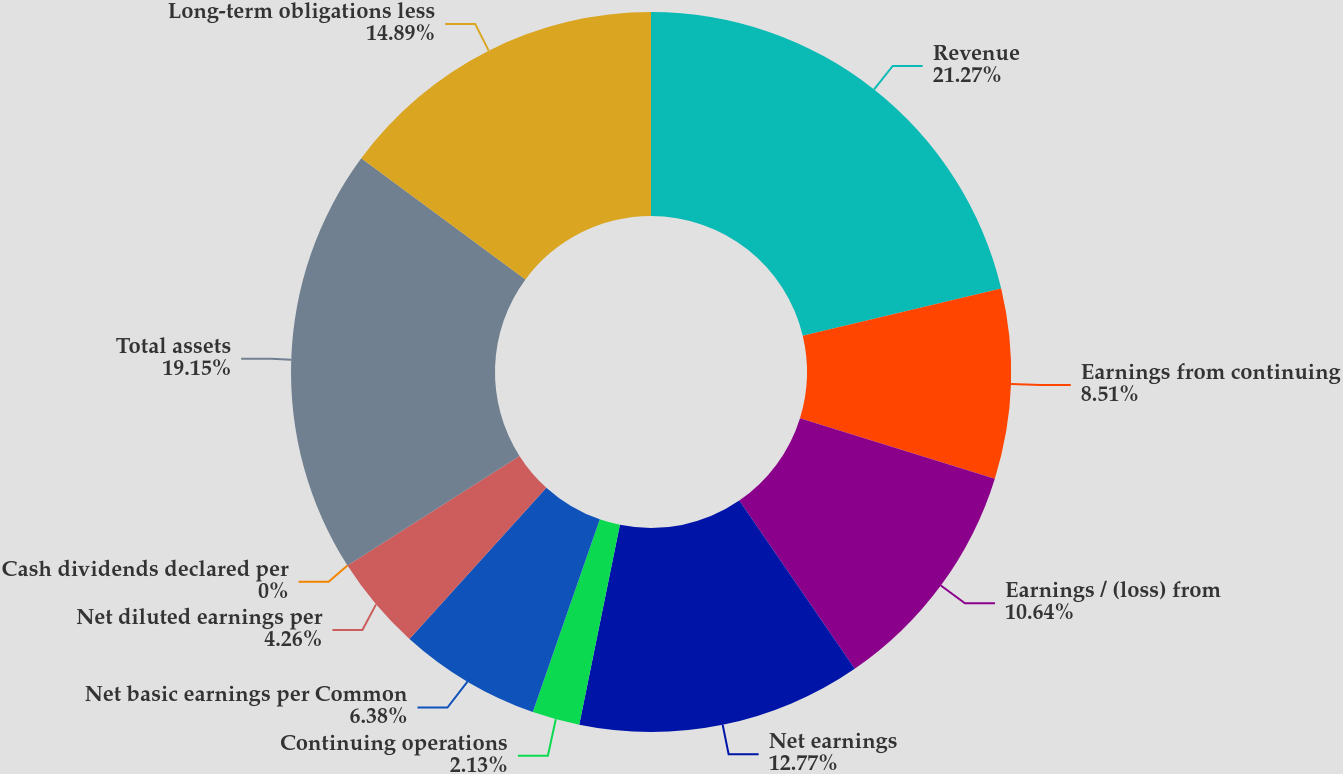<chart> <loc_0><loc_0><loc_500><loc_500><pie_chart><fcel>Revenue<fcel>Earnings from continuing<fcel>Earnings / (loss) from<fcel>Net earnings<fcel>Continuing operations<fcel>Net basic earnings per Common<fcel>Net diluted earnings per<fcel>Cash dividends declared per<fcel>Total assets<fcel>Long-term obligations less<nl><fcel>21.28%<fcel>8.51%<fcel>10.64%<fcel>12.77%<fcel>2.13%<fcel>6.38%<fcel>4.26%<fcel>0.0%<fcel>19.15%<fcel>14.89%<nl></chart> 